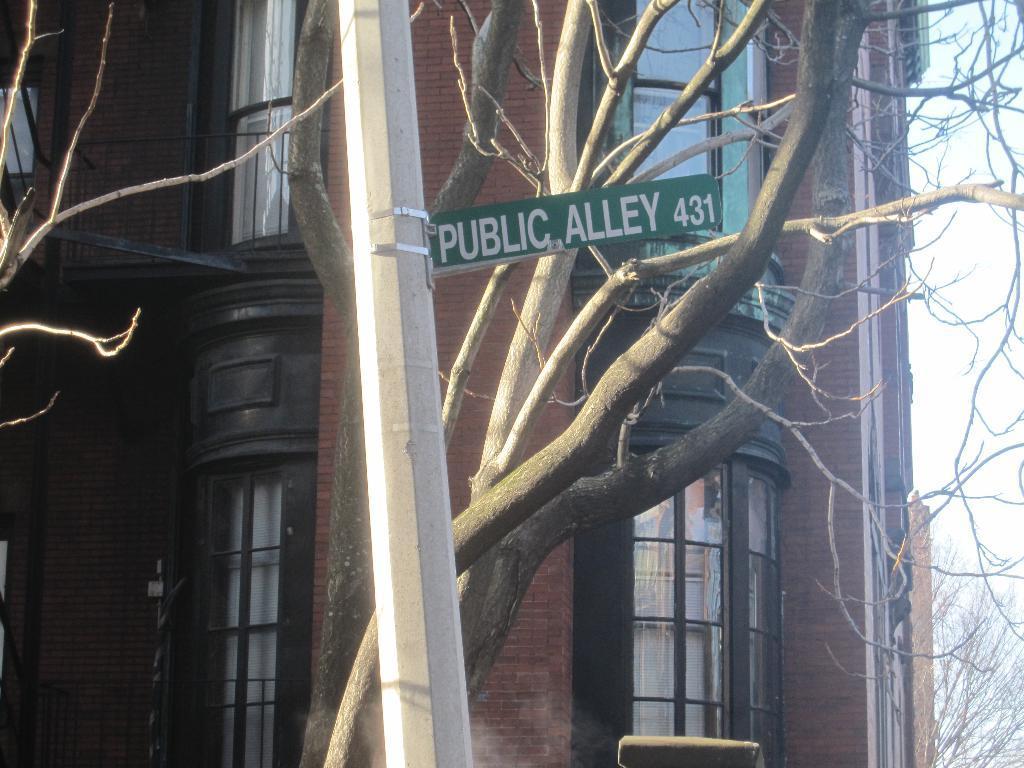How would you summarize this image in a sentence or two? There is a pole with a sign board on that. In the back there are trees and building with windows. On the right side there is sky and tree. 